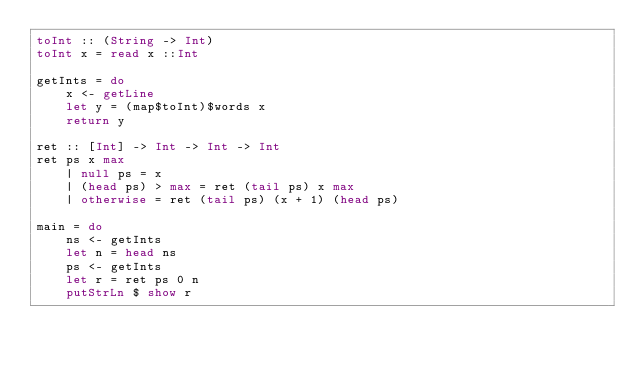<code> <loc_0><loc_0><loc_500><loc_500><_Haskell_>toInt :: (String -> Int)
toInt x = read x ::Int

getInts = do
    x <- getLine
    let y = (map$toInt)$words x
    return y

ret :: [Int] -> Int -> Int -> Int
ret ps x max
    | null ps = x
    | (head ps) > max = ret (tail ps) x max
    | otherwise = ret (tail ps) (x + 1) (head ps)

main = do
    ns <- getInts
    let n = head ns
    ps <- getInts
    let r = ret ps 0 n
    putStrLn $ show r
</code> 